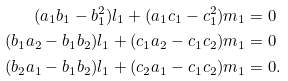<formula> <loc_0><loc_0><loc_500><loc_500>( a _ { 1 } b _ { 1 } - b _ { 1 } ^ { 2 } ) l _ { 1 } + ( a _ { 1 } c _ { 1 } - c _ { 1 } ^ { 2 } ) m _ { 1 } & = 0 \\ ( b _ { 1 } a _ { 2 } - b _ { 1 } b _ { 2 } ) l _ { 1 } + ( c _ { 1 } a _ { 2 } - c _ { 1 } c _ { 2 } ) m _ { 1 } & = 0 \\ ( b _ { 2 } a _ { 1 } - b _ { 1 } b _ { 2 } ) l _ { 1 } + ( c _ { 2 } a _ { 1 } - c _ { 1 } c _ { 2 } ) m _ { 1 } & = 0 .</formula> 